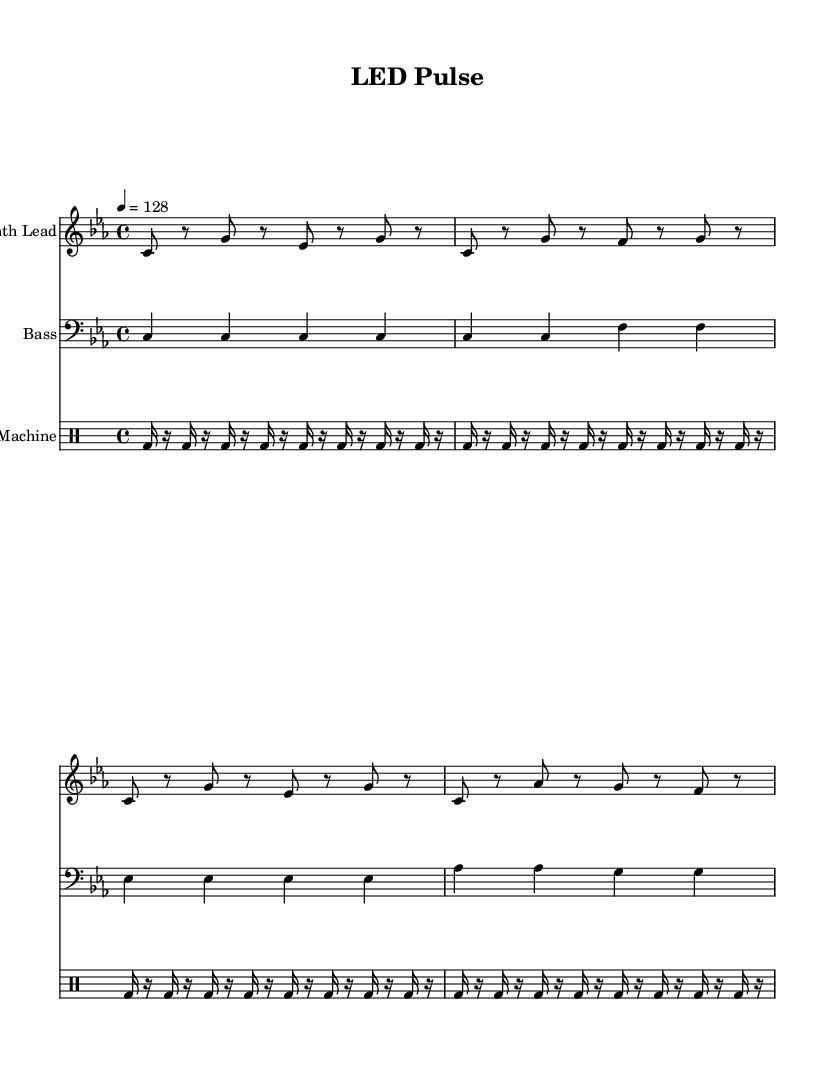What is the key signature of this music? The key signature is C minor, indicated by the presence of three flats in the key signature.
Answer: C minor What is the time signature of this music? The time signature is 4/4, as shown at the beginning of the score. This means there are four beats per measure, and each beat is a quarter note.
Answer: 4/4 What is the tempo marking for this piece? The tempo marking is 128 beats per minute, noted in the score as "4 = 128". This indicates the speed of the music.
Answer: 128 How many measures are in the Synth Lead section? The Synth Lead section contains four measures, which can be counted based on the notated bars in the staff.
Answer: 4 What type of drum rhythm is used in this piece? The drum pattern consists of a bass drum on 16th notes, as indicated by the `bd16` notation in the drum staff.
Answer: Bass drum Which musical element mimics LED light sequences? The Synth Lead uses rhythmic patterns that create a pulsing effect, simulating the on-and-off nature of LED light sequences. This can be seen in the alternating notes and rests.
Answer: Synth Lead What is the last note of the Bass part? The last note of the Bass part is G, found at the end of the last measure in the bass staff.
Answer: G 